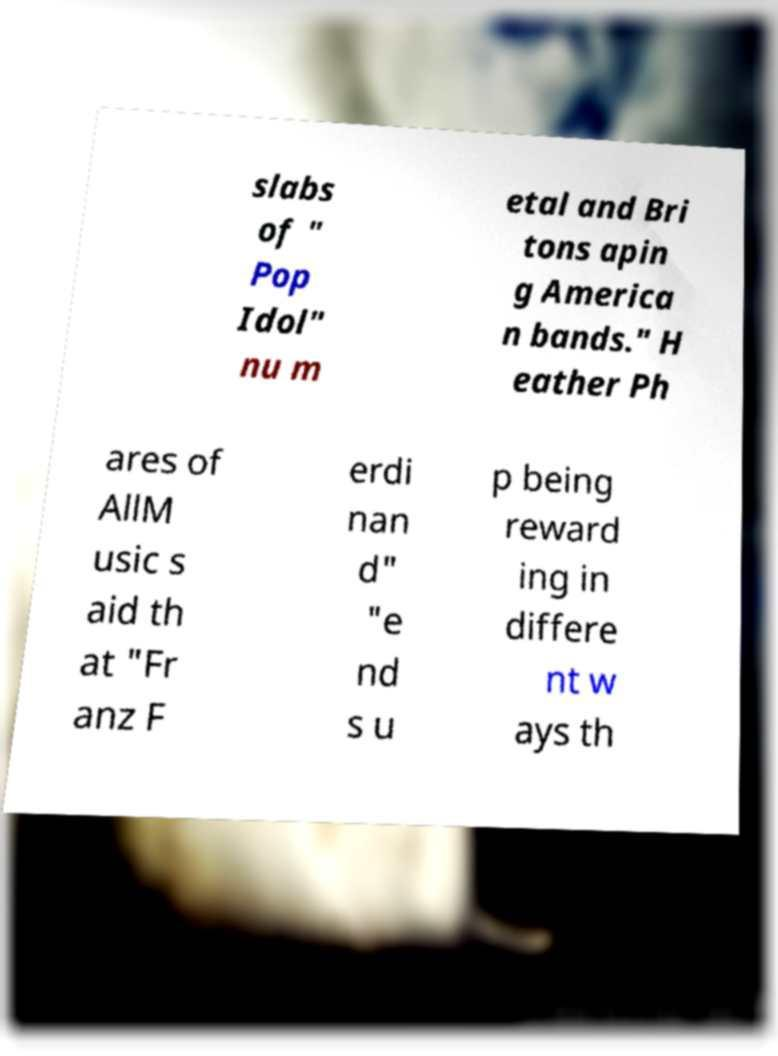Please read and relay the text visible in this image. What does it say? slabs of " Pop Idol" nu m etal and Bri tons apin g America n bands." H eather Ph ares of AllM usic s aid th at "Fr anz F erdi nan d" "e nd s u p being reward ing in differe nt w ays th 